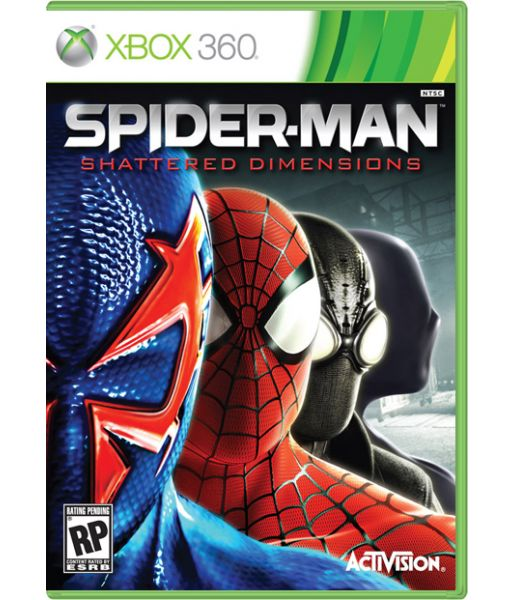In a realistic scenario, how might the different dimensions impact the overall length and complexity of the game? In a realistic scenario, the presence of different dimensions in 'Shattered Dimensions' would likely increase both the overall length and complexity of the game. Each dimension representing a different version of Spider-Man and offering unique mechanics and challenges means additional levels, story arcs, and gameplay elements to explore. Players would need to adapt to different fighting styles, puzzle-solving strategies, and enemies in each dimension. This variation could lead to a more layered and intricate storyline with multiple climactic points, increasing the game's depth and requiring more time to complete. Consequently, the game's complexity would also elevate, as players navigate through diverse environments and manage distinct abilities specific to each dimension.  Describe a new gameplay feature that could be introduced in the game based on the 'Shattered Dimensions' theme. A new gameplay feature that could be introduced in 'Shattered Dimensions' is the 'Dimensional Rift' mechanic. This feature allows Spider-Man to temporarily merge elements from different dimensions, altering the combat and exploration dynamics. For example, in the middle of a battle, Spider-Man can activate a rift to pull in technological traps from the futuristic dimension or shadowy illusions from the noir dimension to confuse and combat enemies. In exploration, this rift could help navigate through obstacles by blending structures from various dimensions, creating new paths or solutions. This innovative mechanic would emphasize strategic thinking, giving players the flexibility to harness abilities from multiple dimensions, and adding an extra layer of tactical depth to both combat and puzzle-solving. 